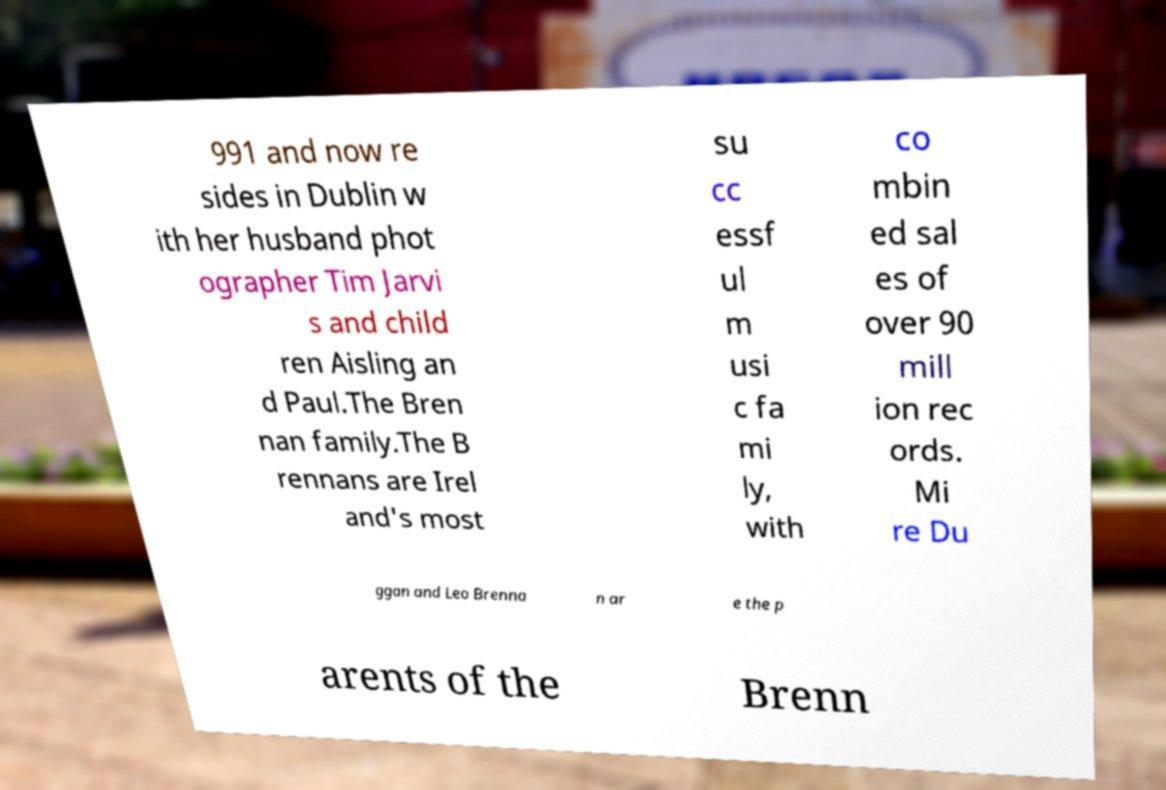There's text embedded in this image that I need extracted. Can you transcribe it verbatim? 991 and now re sides in Dublin w ith her husband phot ographer Tim Jarvi s and child ren Aisling an d Paul.The Bren nan family.The B rennans are Irel and's most su cc essf ul m usi c fa mi ly, with co mbin ed sal es of over 90 mill ion rec ords. Mi re Du ggan and Leo Brenna n ar e the p arents of the Brenn 